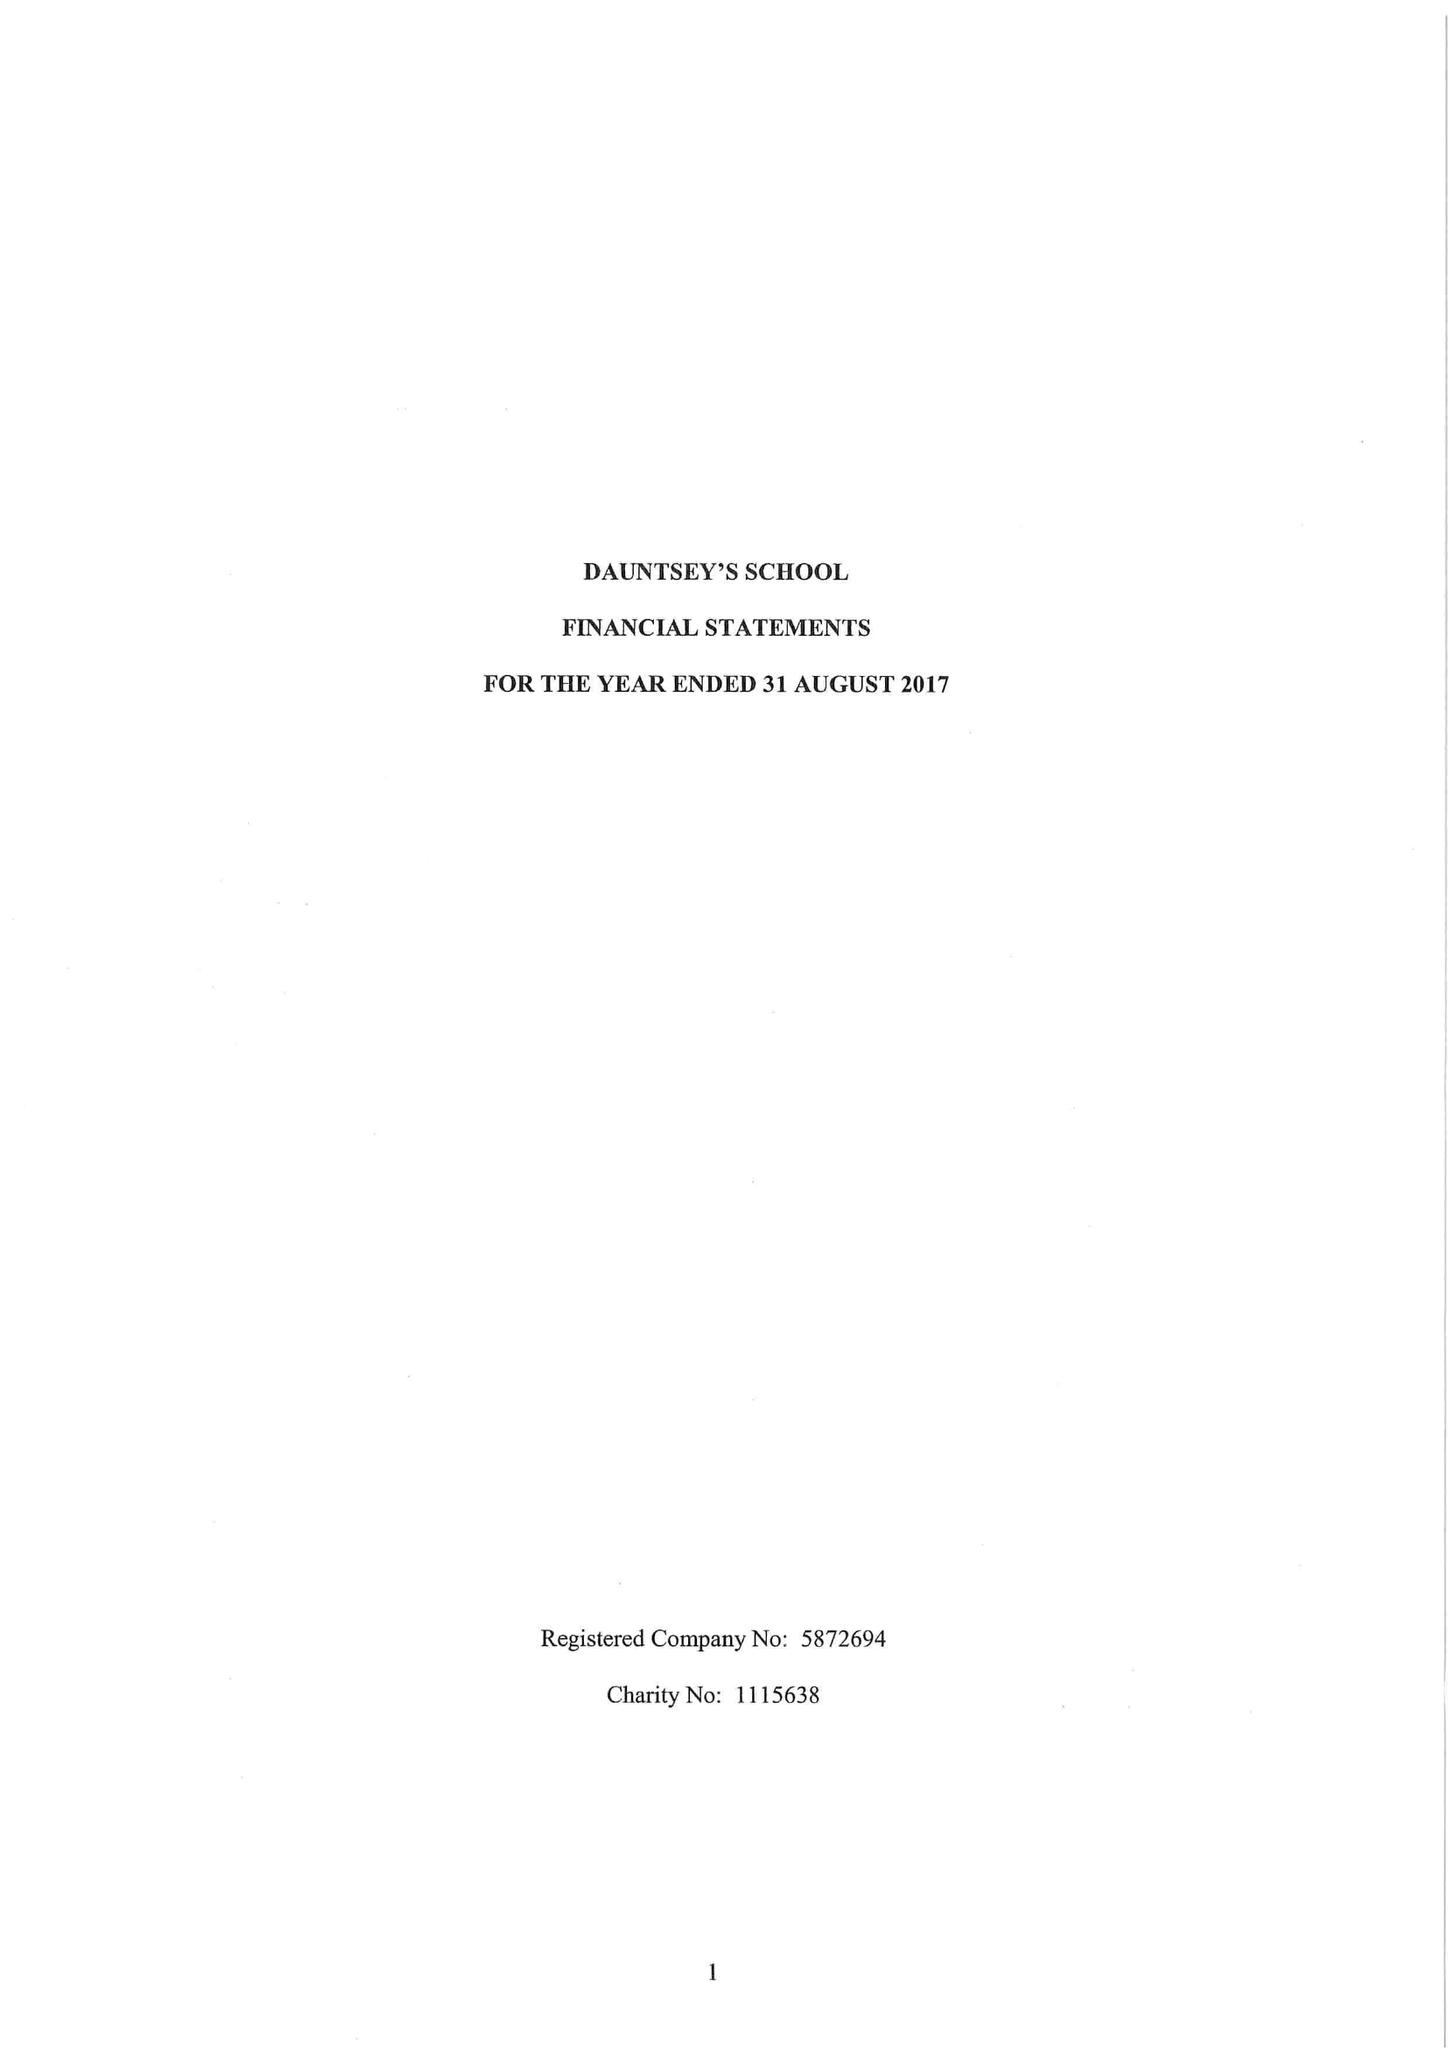What is the value for the income_annually_in_british_pounds?
Answer the question using a single word or phrase. 18217418.00 